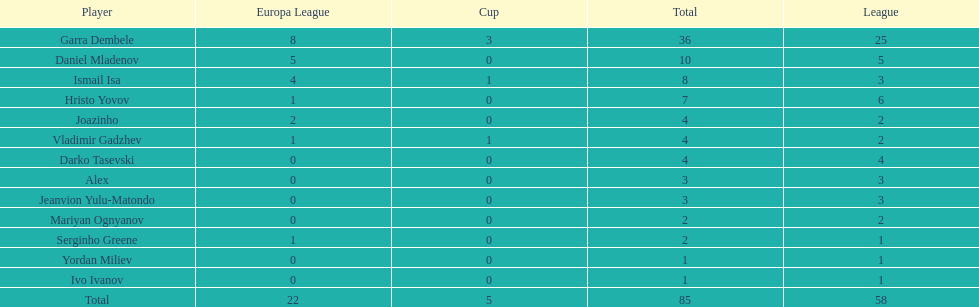What is the sum of the cup total and the europa league total? 27. 